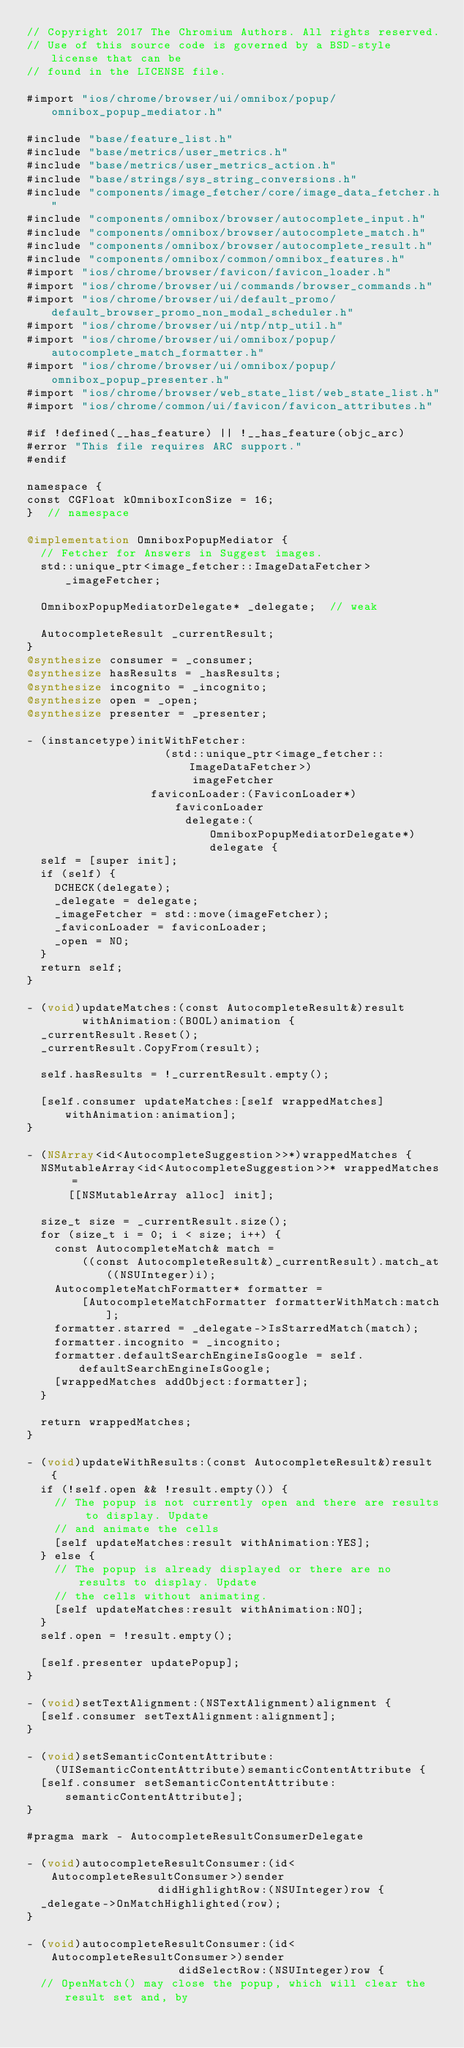<code> <loc_0><loc_0><loc_500><loc_500><_ObjectiveC_>// Copyright 2017 The Chromium Authors. All rights reserved.
// Use of this source code is governed by a BSD-style license that can be
// found in the LICENSE file.

#import "ios/chrome/browser/ui/omnibox/popup/omnibox_popup_mediator.h"

#include "base/feature_list.h"
#include "base/metrics/user_metrics.h"
#include "base/metrics/user_metrics_action.h"
#include "base/strings/sys_string_conversions.h"
#include "components/image_fetcher/core/image_data_fetcher.h"
#include "components/omnibox/browser/autocomplete_input.h"
#include "components/omnibox/browser/autocomplete_match.h"
#include "components/omnibox/browser/autocomplete_result.h"
#include "components/omnibox/common/omnibox_features.h"
#import "ios/chrome/browser/favicon/favicon_loader.h"
#import "ios/chrome/browser/ui/commands/browser_commands.h"
#import "ios/chrome/browser/ui/default_promo/default_browser_promo_non_modal_scheduler.h"
#import "ios/chrome/browser/ui/ntp/ntp_util.h"
#import "ios/chrome/browser/ui/omnibox/popup/autocomplete_match_formatter.h"
#import "ios/chrome/browser/ui/omnibox/popup/omnibox_popup_presenter.h"
#import "ios/chrome/browser/web_state_list/web_state_list.h"
#import "ios/chrome/common/ui/favicon/favicon_attributes.h"

#if !defined(__has_feature) || !__has_feature(objc_arc)
#error "This file requires ARC support."
#endif

namespace {
const CGFloat kOmniboxIconSize = 16;
}  // namespace

@implementation OmniboxPopupMediator {
  // Fetcher for Answers in Suggest images.
  std::unique_ptr<image_fetcher::ImageDataFetcher> _imageFetcher;

  OmniboxPopupMediatorDelegate* _delegate;  // weak

  AutocompleteResult _currentResult;
}
@synthesize consumer = _consumer;
@synthesize hasResults = _hasResults;
@synthesize incognito = _incognito;
@synthesize open = _open;
@synthesize presenter = _presenter;

- (instancetype)initWithFetcher:
                    (std::unique_ptr<image_fetcher::ImageDataFetcher>)
                        imageFetcher
                  faviconLoader:(FaviconLoader*)faviconLoader
                       delegate:(OmniboxPopupMediatorDelegate*)delegate {
  self = [super init];
  if (self) {
    DCHECK(delegate);
    _delegate = delegate;
    _imageFetcher = std::move(imageFetcher);
    _faviconLoader = faviconLoader;
    _open = NO;
  }
  return self;
}

- (void)updateMatches:(const AutocompleteResult&)result
        withAnimation:(BOOL)animation {
  _currentResult.Reset();
  _currentResult.CopyFrom(result);

  self.hasResults = !_currentResult.empty();

  [self.consumer updateMatches:[self wrappedMatches] withAnimation:animation];
}

- (NSArray<id<AutocompleteSuggestion>>*)wrappedMatches {
  NSMutableArray<id<AutocompleteSuggestion>>* wrappedMatches =
      [[NSMutableArray alloc] init];

  size_t size = _currentResult.size();
  for (size_t i = 0; i < size; i++) {
    const AutocompleteMatch& match =
        ((const AutocompleteResult&)_currentResult).match_at((NSUInteger)i);
    AutocompleteMatchFormatter* formatter =
        [AutocompleteMatchFormatter formatterWithMatch:match];
    formatter.starred = _delegate->IsStarredMatch(match);
    formatter.incognito = _incognito;
    formatter.defaultSearchEngineIsGoogle = self.defaultSearchEngineIsGoogle;
    [wrappedMatches addObject:formatter];
  }

  return wrappedMatches;
}

- (void)updateWithResults:(const AutocompleteResult&)result {
  if (!self.open && !result.empty()) {
    // The popup is not currently open and there are results to display. Update
    // and animate the cells
    [self updateMatches:result withAnimation:YES];
  } else {
    // The popup is already displayed or there are no results to display. Update
    // the cells without animating.
    [self updateMatches:result withAnimation:NO];
  }
  self.open = !result.empty();

  [self.presenter updatePopup];
}

- (void)setTextAlignment:(NSTextAlignment)alignment {
  [self.consumer setTextAlignment:alignment];
}

- (void)setSemanticContentAttribute:
    (UISemanticContentAttribute)semanticContentAttribute {
  [self.consumer setSemanticContentAttribute:semanticContentAttribute];
}

#pragma mark - AutocompleteResultConsumerDelegate

- (void)autocompleteResultConsumer:(id<AutocompleteResultConsumer>)sender
                   didHighlightRow:(NSUInteger)row {
  _delegate->OnMatchHighlighted(row);
}

- (void)autocompleteResultConsumer:(id<AutocompleteResultConsumer>)sender
                      didSelectRow:(NSUInteger)row {
  // OpenMatch() may close the popup, which will clear the result set and, by</code> 